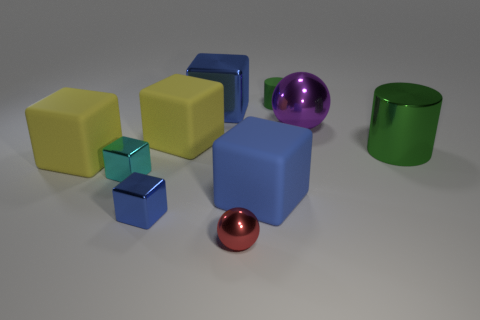Subtract all yellow spheres. How many blue blocks are left? 3 Subtract 2 cubes. How many cubes are left? 4 Subtract all cyan cubes. How many cubes are left? 5 Subtract all cyan cubes. How many cubes are left? 5 Subtract all gray blocks. Subtract all red balls. How many blocks are left? 6 Subtract all spheres. How many objects are left? 8 Subtract 0 blue balls. How many objects are left? 10 Subtract all large blue objects. Subtract all big shiny objects. How many objects are left? 5 Add 4 small metallic spheres. How many small metallic spheres are left? 5 Add 9 big purple cylinders. How many big purple cylinders exist? 9 